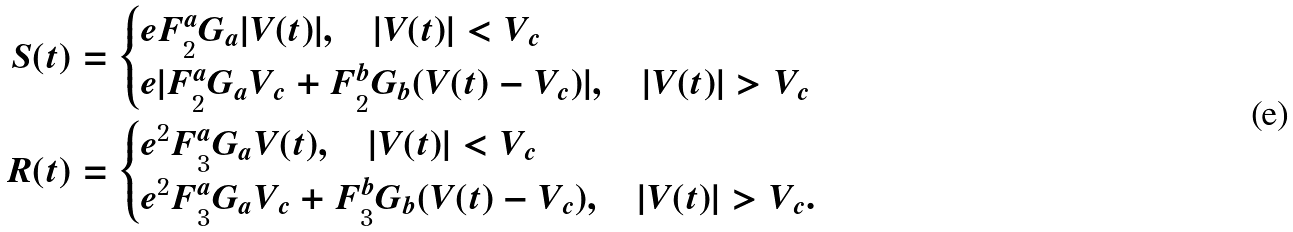Convert formula to latex. <formula><loc_0><loc_0><loc_500><loc_500>S ( t ) & = \begin{cases} e F _ { 2 } ^ { a } G _ { a } | V ( t ) | , \quad | V ( t ) | < V _ { c } \\ e | F _ { 2 } ^ { a } G _ { a } V _ { c } + F _ { 2 } ^ { b } G _ { b } ( V ( t ) - V _ { c } ) | , \quad | V ( t ) | > V _ { c } \end{cases} \\ R ( t ) & = \begin{cases} e ^ { 2 } F _ { 3 } ^ { a } G _ { a } V ( t ) , \quad | V ( t ) | < V _ { c } \\ e ^ { 2 } F _ { 3 } ^ { a } G _ { a } V _ { c } + F _ { 3 } ^ { b } G _ { b } ( V ( t ) - V _ { c } ) , \quad | V ( t ) | > V _ { c } . \end{cases}</formula> 